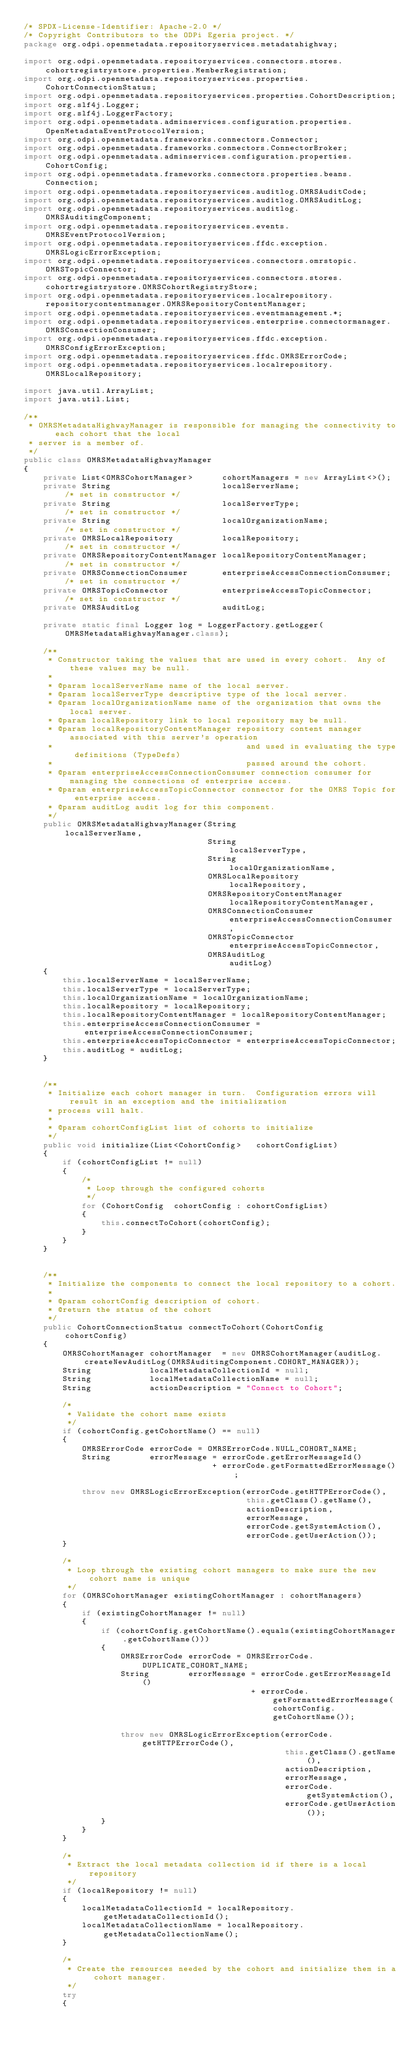<code> <loc_0><loc_0><loc_500><loc_500><_Java_>/* SPDX-License-Identifier: Apache-2.0 */
/* Copyright Contributors to the ODPi Egeria project. */
package org.odpi.openmetadata.repositoryservices.metadatahighway;

import org.odpi.openmetadata.repositoryservices.connectors.stores.cohortregistrystore.properties.MemberRegistration;
import org.odpi.openmetadata.repositoryservices.properties.CohortConnectionStatus;
import org.odpi.openmetadata.repositoryservices.properties.CohortDescription;
import org.slf4j.Logger;
import org.slf4j.LoggerFactory;
import org.odpi.openmetadata.adminservices.configuration.properties.OpenMetadataEventProtocolVersion;
import org.odpi.openmetadata.frameworks.connectors.Connector;
import org.odpi.openmetadata.frameworks.connectors.ConnectorBroker;
import org.odpi.openmetadata.adminservices.configuration.properties.CohortConfig;
import org.odpi.openmetadata.frameworks.connectors.properties.beans.Connection;
import org.odpi.openmetadata.repositoryservices.auditlog.OMRSAuditCode;
import org.odpi.openmetadata.repositoryservices.auditlog.OMRSAuditLog;
import org.odpi.openmetadata.repositoryservices.auditlog.OMRSAuditingComponent;
import org.odpi.openmetadata.repositoryservices.events.OMRSEventProtocolVersion;
import org.odpi.openmetadata.repositoryservices.ffdc.exception.OMRSLogicErrorException;
import org.odpi.openmetadata.repositoryservices.connectors.omrstopic.OMRSTopicConnector;
import org.odpi.openmetadata.repositoryservices.connectors.stores.cohortregistrystore.OMRSCohortRegistryStore;
import org.odpi.openmetadata.repositoryservices.localrepository.repositorycontentmanager.OMRSRepositoryContentManager;
import org.odpi.openmetadata.repositoryservices.eventmanagement.*;
import org.odpi.openmetadata.repositoryservices.enterprise.connectormanager.OMRSConnectionConsumer;
import org.odpi.openmetadata.repositoryservices.ffdc.exception.OMRSConfigErrorException;
import org.odpi.openmetadata.repositoryservices.ffdc.OMRSErrorCode;
import org.odpi.openmetadata.repositoryservices.localrepository.OMRSLocalRepository;

import java.util.ArrayList;
import java.util.List;

/**
 * OMRSMetadataHighwayManager is responsible for managing the connectivity to each cohort that the local
 * server is a member of.
 */
public class OMRSMetadataHighwayManager
{
    private List<OMRSCohortManager>      cohortManagers = new ArrayList<>();
    private String                       localServerName;                    /* set in constructor */
    private String                       localServerType;                    /* set in constructor */
    private String                       localOrganizationName;              /* set in constructor */
    private OMRSLocalRepository          localRepository;                    /* set in constructor */
    private OMRSRepositoryContentManager localRepositoryContentManager;      /* set in constructor */
    private OMRSConnectionConsumer       enterpriseAccessConnectionConsumer; /* set in constructor */
    private OMRSTopicConnector           enterpriseAccessTopicConnector;     /* set in constructor */
    private OMRSAuditLog                 auditLog;

    private static final Logger log = LoggerFactory.getLogger(OMRSMetadataHighwayManager.class);

    /**
     * Constructor taking the values that are used in every cohort.  Any of these values may be null.
     *
     * @param localServerName name of the local server.
     * @param localServerType descriptive type of the local server.
     * @param localOrganizationName name of the organization that owns the local server.
     * @param localRepository link to local repository may be null.
     * @param localRepositoryContentManager repository content manager associated with this server's operation
     *                                        and used in evaluating the type definitions (TypeDefs)
     *                                        passed around the cohort.
     * @param enterpriseAccessConnectionConsumer connection consumer for managing the connections of enterprise access.
     * @param enterpriseAccessTopicConnector connector for the OMRS Topic for enterprise access.
     * @param auditLog audit log for this component.
     */
    public OMRSMetadataHighwayManager(String                          localServerName,
                                      String                          localServerType,
                                      String                          localOrganizationName,
                                      OMRSLocalRepository             localRepository,
                                      OMRSRepositoryContentManager    localRepositoryContentManager,
                                      OMRSConnectionConsumer          enterpriseAccessConnectionConsumer,
                                      OMRSTopicConnector              enterpriseAccessTopicConnector,
                                      OMRSAuditLog                    auditLog)
    {
        this.localServerName = localServerName;
        this.localServerType = localServerType;
        this.localOrganizationName = localOrganizationName;
        this.localRepository = localRepository;
        this.localRepositoryContentManager = localRepositoryContentManager;
        this.enterpriseAccessConnectionConsumer = enterpriseAccessConnectionConsumer;
        this.enterpriseAccessTopicConnector = enterpriseAccessTopicConnector;
        this.auditLog = auditLog;
    }


    /**
     * Initialize each cohort manager in turn.  Configuration errors will result in an exception and the initialization
     * process will halt.
     *
     * @param cohortConfigList list of cohorts to initialize
     */
    public void initialize(List<CohortConfig>   cohortConfigList)
    {
        if (cohortConfigList != null)
        {
            /*
             * Loop through the configured cohorts
             */
            for (CohortConfig  cohortConfig : cohortConfigList)
            {
                this.connectToCohort(cohortConfig);
            }
        }
    }


    /**
     * Initialize the components to connect the local repository to a cohort.
     *
     * @param cohortConfig description of cohort.
     * @return the status of the cohort
     */
    public CohortConnectionStatus connectToCohort(CohortConfig         cohortConfig)
    {
        OMRSCohortManager cohortManager  = new OMRSCohortManager(auditLog.createNewAuditLog(OMRSAuditingComponent.COHORT_MANAGER));
        String            localMetadataCollectionId = null;
        String            localMetadataCollectionName = null;
        String            actionDescription = "Connect to Cohort";

        /*
         * Validate the cohort name exists
         */
        if (cohortConfig.getCohortName() == null)
        {
            OMRSErrorCode errorCode = OMRSErrorCode.NULL_COHORT_NAME;
            String        errorMessage = errorCode.getErrorMessageId()
                                       + errorCode.getFormattedErrorMessage();

            throw new OMRSLogicErrorException(errorCode.getHTTPErrorCode(),
                                              this.getClass().getName(),
                                              actionDescription,
                                              errorMessage,
                                              errorCode.getSystemAction(),
                                              errorCode.getUserAction());
        }

        /*
         * Loop through the existing cohort managers to make sure the new cohort name is unique
         */
        for (OMRSCohortManager existingCohortManager : cohortManagers)
        {
            if (existingCohortManager != null)
            {
                if (cohortConfig.getCohortName().equals(existingCohortManager.getCohortName()))
                {
                    OMRSErrorCode errorCode = OMRSErrorCode.DUPLICATE_COHORT_NAME;
                    String        errorMessage = errorCode.getErrorMessageId()
                                               + errorCode.getFormattedErrorMessage(cohortConfig.getCohortName());

                    throw new OMRSLogicErrorException(errorCode.getHTTPErrorCode(),
                                                      this.getClass().getName(),
                                                      actionDescription,
                                                      errorMessage,
                                                      errorCode.getSystemAction(),
                                                      errorCode.getUserAction());
                }
            }
        }

        /*
         * Extract the local metadata collection id if there is a local repository
         */
        if (localRepository != null)
        {
            localMetadataCollectionId = localRepository.getMetadataCollectionId();
            localMetadataCollectionName = localRepository.getMetadataCollectionName();
        }

        /*
         * Create the resources needed by the cohort and initialize them in a cohort manager.
         */
        try
        {</code> 